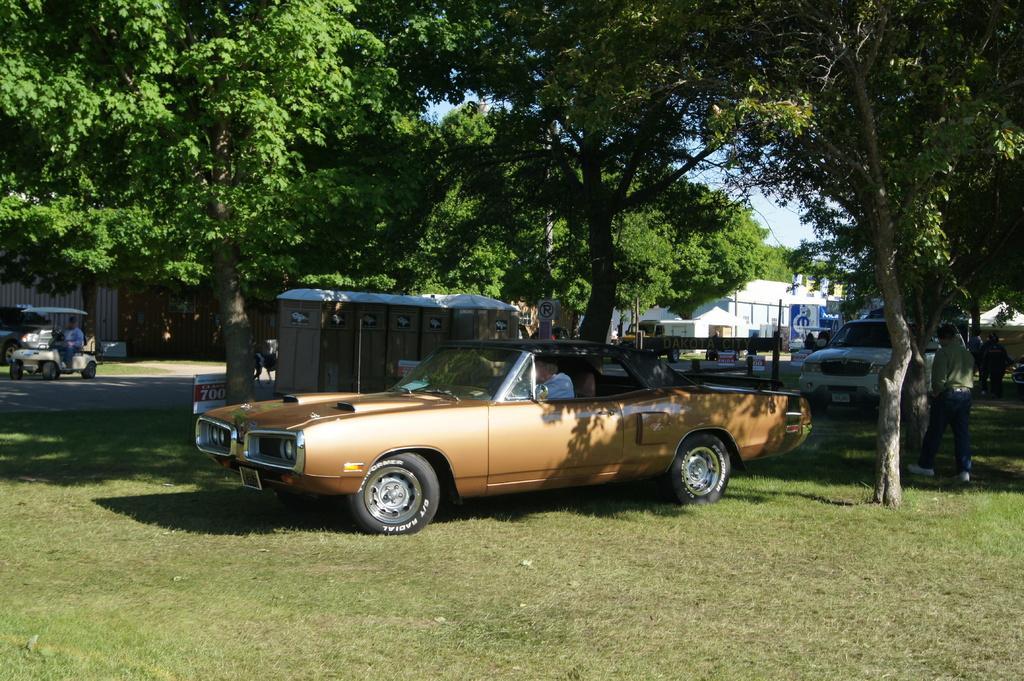Could you give a brief overview of what you see in this image? Here in this picture we can see vehicles present on the ground, which is fully covered with grass over there and in the far we can see some buildings present over there and we can see trees and plants also present over there and we can see people walking and standing on the ground here and there. 